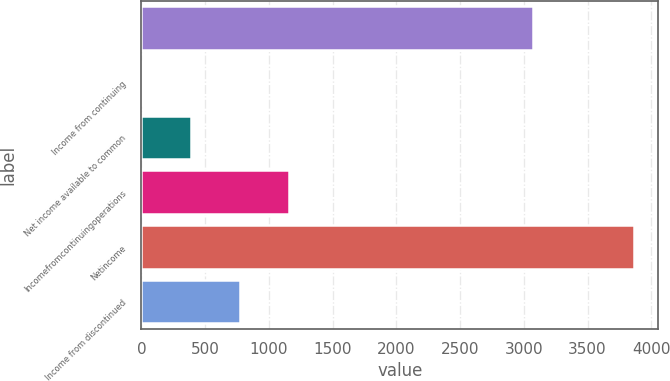<chart> <loc_0><loc_0><loc_500><loc_500><bar_chart><ecel><fcel>Income from continuing<fcel>Net income available to common<fcel>Incomefromcontinuingoperations<fcel>Netincome<fcel>Income from discontinued<nl><fcel>3069<fcel>1.47<fcel>387.62<fcel>1159.92<fcel>3863<fcel>773.77<nl></chart> 